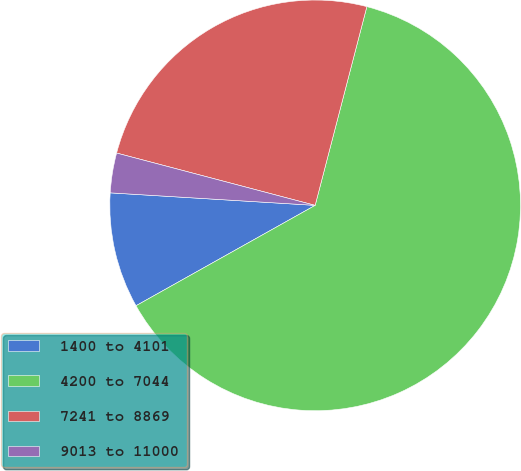Convert chart. <chart><loc_0><loc_0><loc_500><loc_500><pie_chart><fcel>1400 to 4101<fcel>4200 to 7044<fcel>7241 to 8869<fcel>9013 to 11000<nl><fcel>9.1%<fcel>62.82%<fcel>24.95%<fcel>3.13%<nl></chart> 